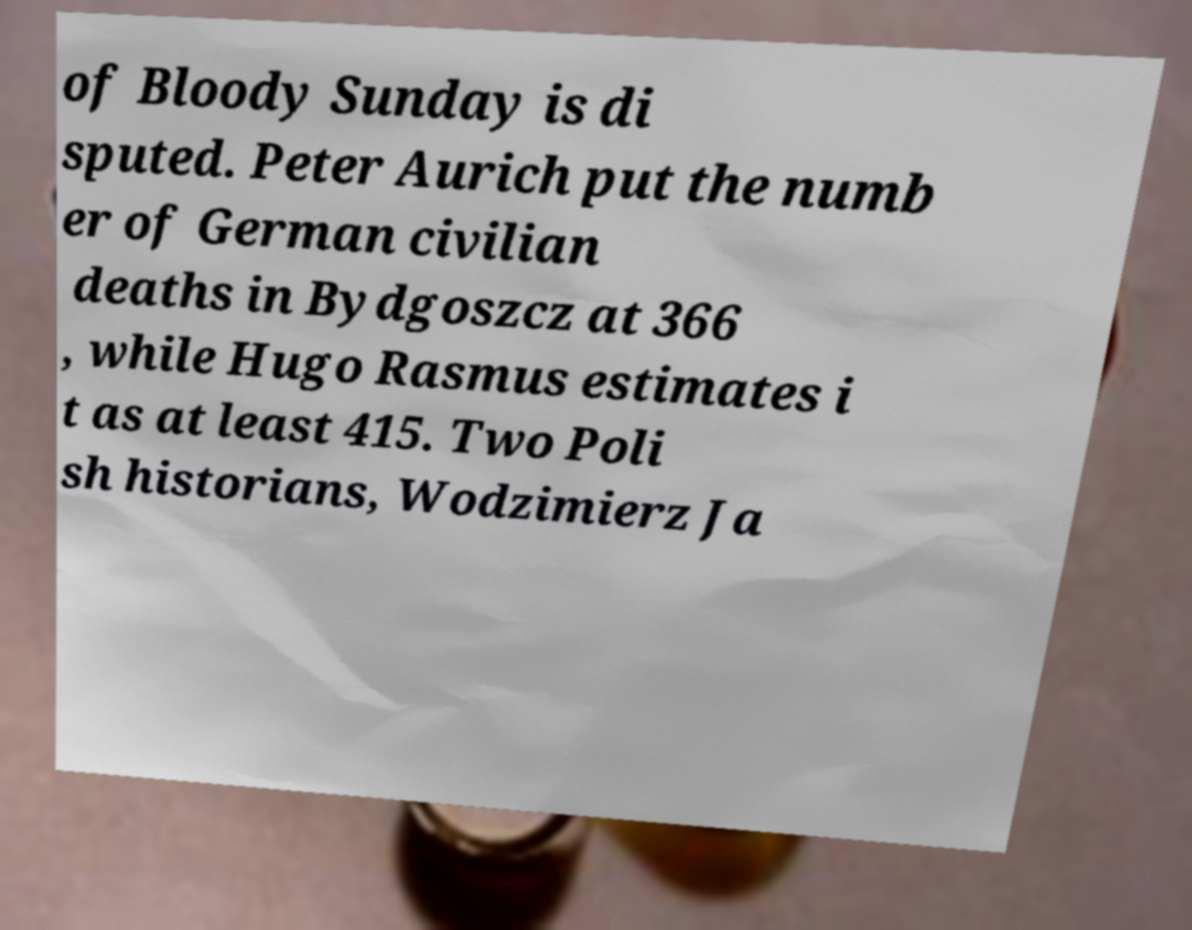Could you extract and type out the text from this image? of Bloody Sunday is di sputed. Peter Aurich put the numb er of German civilian deaths in Bydgoszcz at 366 , while Hugo Rasmus estimates i t as at least 415. Two Poli sh historians, Wodzimierz Ja 